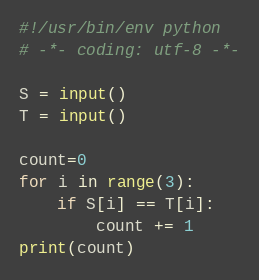Convert code to text. <code><loc_0><loc_0><loc_500><loc_500><_Python_>#!/usr/bin/env python
# -*- coding: utf-8 -*-

S = input()
T = input()

count=0
for i in range(3):
    if S[i] == T[i]:
        count += 1
print(count)
</code> 